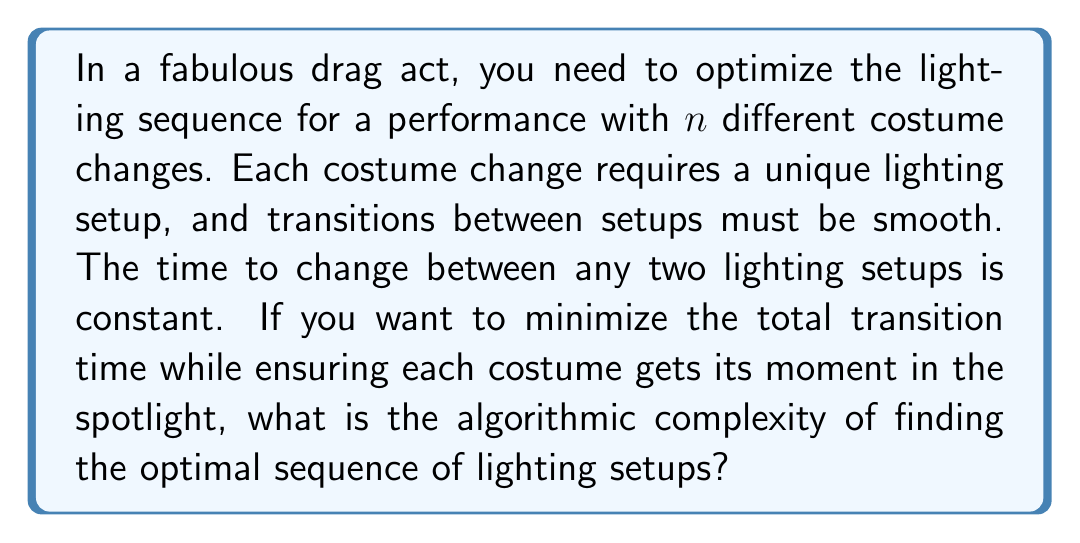Can you answer this question? Let's approach this step-by-step:

1) This problem is essentially a variation of the Traveling Salesman Problem (TSP), where instead of cities, we have lighting setups, and instead of distances, we have transition times.

2) In this case, we want to visit all lighting setups exactly once, minimizing the total transition time. This is equivalent to finding the shortest Hamiltonian cycle in a complete graph with $n$ vertices.

3) The key differences from the standard TSP are:
   a) All edge weights (transition times) are equal.
   b) We don't need to return to the starting point.

4) Despite these simplifications, the problem remains NP-hard. The number of possible permutations is $(n-1)!$, as we can fix the first lighting setup and permute the rest.

5) The best known exact algorithms for solving TSP have a time complexity of $O(2^n \cdot n^2)$, where $n$ is the number of vertices (lighting setups in our case).

6) However, given that all transition times are equal, this problem reduces to finding a Hamiltonian path in an unweighted graph, which can be solved in $O(2^n \cdot n)$ time using dynamic programming.

7) The space complexity for this dynamic programming approach would be $O(2^n \cdot n)$ as well.

Therefore, the algorithmic complexity of optimizing the lighting sequence for this fabulous drag act is $O(2^n \cdot n)$ in both time and space.
Answer: The algorithmic complexity is $O(2^n \cdot n)$ for both time and space, where $n$ is the number of costume changes (lighting setups). 